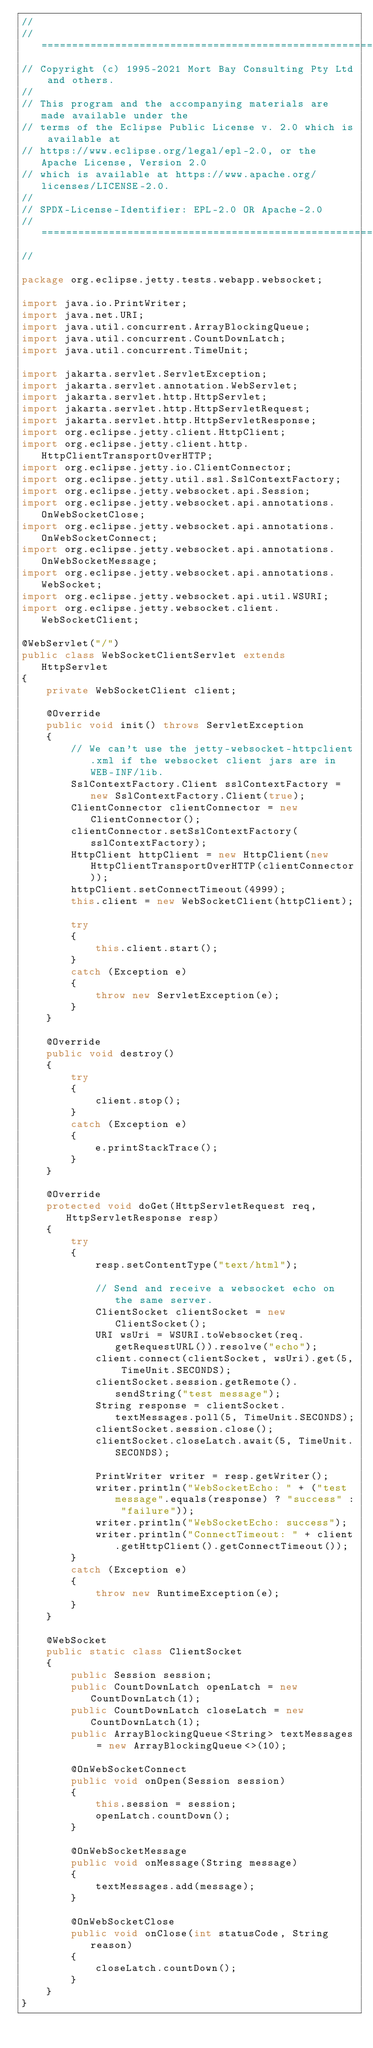<code> <loc_0><loc_0><loc_500><loc_500><_Java_>//
// ========================================================================
// Copyright (c) 1995-2021 Mort Bay Consulting Pty Ltd and others.
//
// This program and the accompanying materials are made available under the
// terms of the Eclipse Public License v. 2.0 which is available at
// https://www.eclipse.org/legal/epl-2.0, or the Apache License, Version 2.0
// which is available at https://www.apache.org/licenses/LICENSE-2.0.
//
// SPDX-License-Identifier: EPL-2.0 OR Apache-2.0
// ========================================================================
//

package org.eclipse.jetty.tests.webapp.websocket;

import java.io.PrintWriter;
import java.net.URI;
import java.util.concurrent.ArrayBlockingQueue;
import java.util.concurrent.CountDownLatch;
import java.util.concurrent.TimeUnit;

import jakarta.servlet.ServletException;
import jakarta.servlet.annotation.WebServlet;
import jakarta.servlet.http.HttpServlet;
import jakarta.servlet.http.HttpServletRequest;
import jakarta.servlet.http.HttpServletResponse;
import org.eclipse.jetty.client.HttpClient;
import org.eclipse.jetty.client.http.HttpClientTransportOverHTTP;
import org.eclipse.jetty.io.ClientConnector;
import org.eclipse.jetty.util.ssl.SslContextFactory;
import org.eclipse.jetty.websocket.api.Session;
import org.eclipse.jetty.websocket.api.annotations.OnWebSocketClose;
import org.eclipse.jetty.websocket.api.annotations.OnWebSocketConnect;
import org.eclipse.jetty.websocket.api.annotations.OnWebSocketMessage;
import org.eclipse.jetty.websocket.api.annotations.WebSocket;
import org.eclipse.jetty.websocket.api.util.WSURI;
import org.eclipse.jetty.websocket.client.WebSocketClient;

@WebServlet("/")
public class WebSocketClientServlet extends HttpServlet
{
    private WebSocketClient client;

    @Override
    public void init() throws ServletException
    {
        // We can't use the jetty-websocket-httpclient.xml if the websocket client jars are in WEB-INF/lib.
        SslContextFactory.Client sslContextFactory = new SslContextFactory.Client(true);
        ClientConnector clientConnector = new ClientConnector();
        clientConnector.setSslContextFactory(sslContextFactory);
        HttpClient httpClient = new HttpClient(new HttpClientTransportOverHTTP(clientConnector));
        httpClient.setConnectTimeout(4999);
        this.client = new WebSocketClient(httpClient);

        try
        {
            this.client.start();
        }
        catch (Exception e)
        {
            throw new ServletException(e);
        }
    }

    @Override
    public void destroy()
    {
        try
        {
            client.stop();
        }
        catch (Exception e)
        {
            e.printStackTrace();
        }
    }

    @Override
    protected void doGet(HttpServletRequest req, HttpServletResponse resp)
    {
        try
        {
            resp.setContentType("text/html");

            // Send and receive a websocket echo on the same server.
            ClientSocket clientSocket = new ClientSocket();
            URI wsUri = WSURI.toWebsocket(req.getRequestURL()).resolve("echo");
            client.connect(clientSocket, wsUri).get(5, TimeUnit.SECONDS);
            clientSocket.session.getRemote().sendString("test message");
            String response = clientSocket.textMessages.poll(5, TimeUnit.SECONDS);
            clientSocket.session.close();
            clientSocket.closeLatch.await(5, TimeUnit.SECONDS);

            PrintWriter writer = resp.getWriter();
            writer.println("WebSocketEcho: " + ("test message".equals(response) ? "success" : "failure"));
            writer.println("WebSocketEcho: success");
            writer.println("ConnectTimeout: " + client.getHttpClient().getConnectTimeout());
        }
        catch (Exception e)
        {
            throw new RuntimeException(e);
        }
    }

    @WebSocket
    public static class ClientSocket
    {
        public Session session;
        public CountDownLatch openLatch = new CountDownLatch(1);
        public CountDownLatch closeLatch = new CountDownLatch(1);
        public ArrayBlockingQueue<String> textMessages = new ArrayBlockingQueue<>(10);

        @OnWebSocketConnect
        public void onOpen(Session session)
        {
            this.session = session;
            openLatch.countDown();
        }

        @OnWebSocketMessage
        public void onMessage(String message)
        {
            textMessages.add(message);
        }

        @OnWebSocketClose
        public void onClose(int statusCode, String reason)
        {
            closeLatch.countDown();
        }
    }
}
</code> 